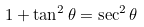Convert formula to latex. <formula><loc_0><loc_0><loc_500><loc_500>1 + \tan ^ { 2 } \theta = \sec ^ { 2 } \theta</formula> 